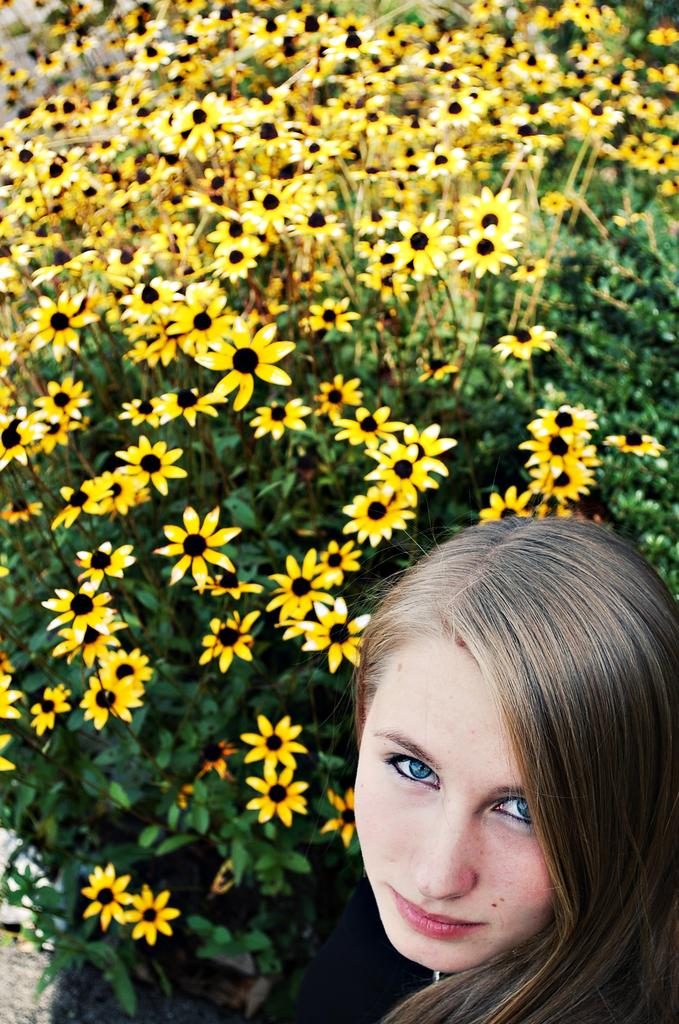What is the main subject in the foreground of the image? There is a woman in the foreground of the image. What can be seen in the background of the image? There are flowers and plants in the background of the image. What type of rifle is the woman holding in the image? There is no rifle present in the image; the woman is not holding any weapon. 